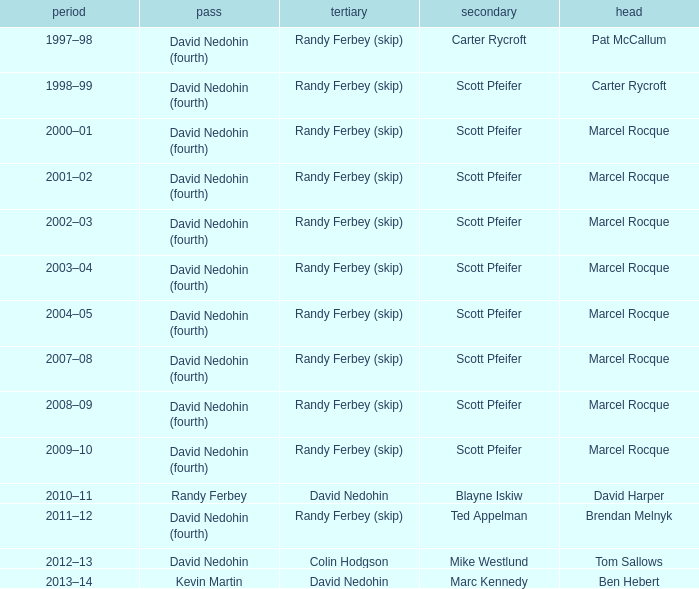Could you parse the entire table as a dict? {'header': ['period', 'pass', 'tertiary', 'secondary', 'head'], 'rows': [['1997–98', 'David Nedohin (fourth)', 'Randy Ferbey (skip)', 'Carter Rycroft', 'Pat McCallum'], ['1998–99', 'David Nedohin (fourth)', 'Randy Ferbey (skip)', 'Scott Pfeifer', 'Carter Rycroft'], ['2000–01', 'David Nedohin (fourth)', 'Randy Ferbey (skip)', 'Scott Pfeifer', 'Marcel Rocque'], ['2001–02', 'David Nedohin (fourth)', 'Randy Ferbey (skip)', 'Scott Pfeifer', 'Marcel Rocque'], ['2002–03', 'David Nedohin (fourth)', 'Randy Ferbey (skip)', 'Scott Pfeifer', 'Marcel Rocque'], ['2003–04', 'David Nedohin (fourth)', 'Randy Ferbey (skip)', 'Scott Pfeifer', 'Marcel Rocque'], ['2004–05', 'David Nedohin (fourth)', 'Randy Ferbey (skip)', 'Scott Pfeifer', 'Marcel Rocque'], ['2007–08', 'David Nedohin (fourth)', 'Randy Ferbey (skip)', 'Scott Pfeifer', 'Marcel Rocque'], ['2008–09', 'David Nedohin (fourth)', 'Randy Ferbey (skip)', 'Scott Pfeifer', 'Marcel Rocque'], ['2009–10', 'David Nedohin (fourth)', 'Randy Ferbey (skip)', 'Scott Pfeifer', 'Marcel Rocque'], ['2010–11', 'Randy Ferbey', 'David Nedohin', 'Blayne Iskiw', 'David Harper'], ['2011–12', 'David Nedohin (fourth)', 'Randy Ferbey (skip)', 'Ted Appelman', 'Brendan Melnyk'], ['2012–13', 'David Nedohin', 'Colin Hodgson', 'Mike Westlund', 'Tom Sallows'], ['2013–14', 'Kevin Martin', 'David Nedohin', 'Marc Kennedy', 'Ben Hebert']]} Which Third has a Second of scott pfeifer? Randy Ferbey (skip), Randy Ferbey (skip), Randy Ferbey (skip), Randy Ferbey (skip), Randy Ferbey (skip), Randy Ferbey (skip), Randy Ferbey (skip), Randy Ferbey (skip), Randy Ferbey (skip). 